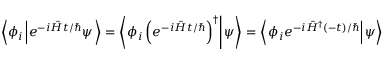<formula> <loc_0><loc_0><loc_500><loc_500>\left \langle \phi _ { i } \left | e ^ { - i { \hat { H } } t / } \psi \right \rangle = \left \langle \phi _ { i } \left ( e ^ { - i { \hat { H } } t / } \right ) ^ { \dagger } \right | \psi \right \rangle = \left \langle \phi _ { i } e ^ { - i { \hat { H } } ^ { \dagger } ( - t ) / } \right | \psi \right \rangle</formula> 